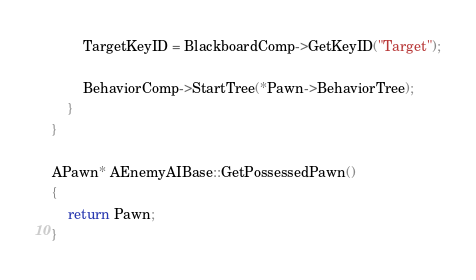Convert code to text. <code><loc_0><loc_0><loc_500><loc_500><_C++_>
		TargetKeyID = BlackboardComp->GetKeyID("Target");

		BehaviorComp->StartTree(*Pawn->BehaviorTree);
	}
}

APawn* AEnemyAIBase::GetPossessedPawn()
{
	return Pawn;
}
</code> 